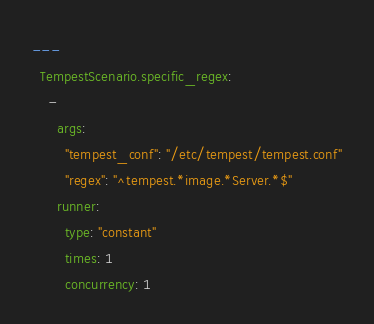Convert code to text. <code><loc_0><loc_0><loc_500><loc_500><_YAML_>---
  TempestScenario.specific_regex:
    -
      args:
        "tempest_conf": "/etc/tempest/tempest.conf"
        "regex": "^tempest.*image.*Server.*$"
      runner:
        type: "constant"
        times: 1
        concurrency: 1
</code> 